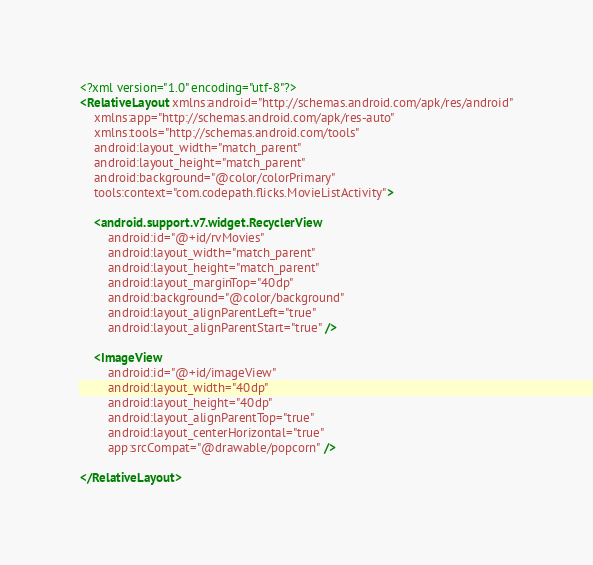<code> <loc_0><loc_0><loc_500><loc_500><_XML_><?xml version="1.0" encoding="utf-8"?>
<RelativeLayout xmlns:android="http://schemas.android.com/apk/res/android"
    xmlns:app="http://schemas.android.com/apk/res-auto"
    xmlns:tools="http://schemas.android.com/tools"
    android:layout_width="match_parent"
    android:layout_height="match_parent"
    android:background="@color/colorPrimary"
    tools:context="com.codepath.flicks.MovieListActivity">

    <android.support.v7.widget.RecyclerView
        android:id="@+id/rvMovies"
        android:layout_width="match_parent"
        android:layout_height="match_parent"
        android:layout_marginTop="40dp"
        android:background="@color/background"
        android:layout_alignParentLeft="true"
        android:layout_alignParentStart="true" />

    <ImageView
        android:id="@+id/imageView"
        android:layout_width="40dp"
        android:layout_height="40dp"
        android:layout_alignParentTop="true"
        android:layout_centerHorizontal="true"
        app:srcCompat="@drawable/popcorn" />

</RelativeLayout>
</code> 